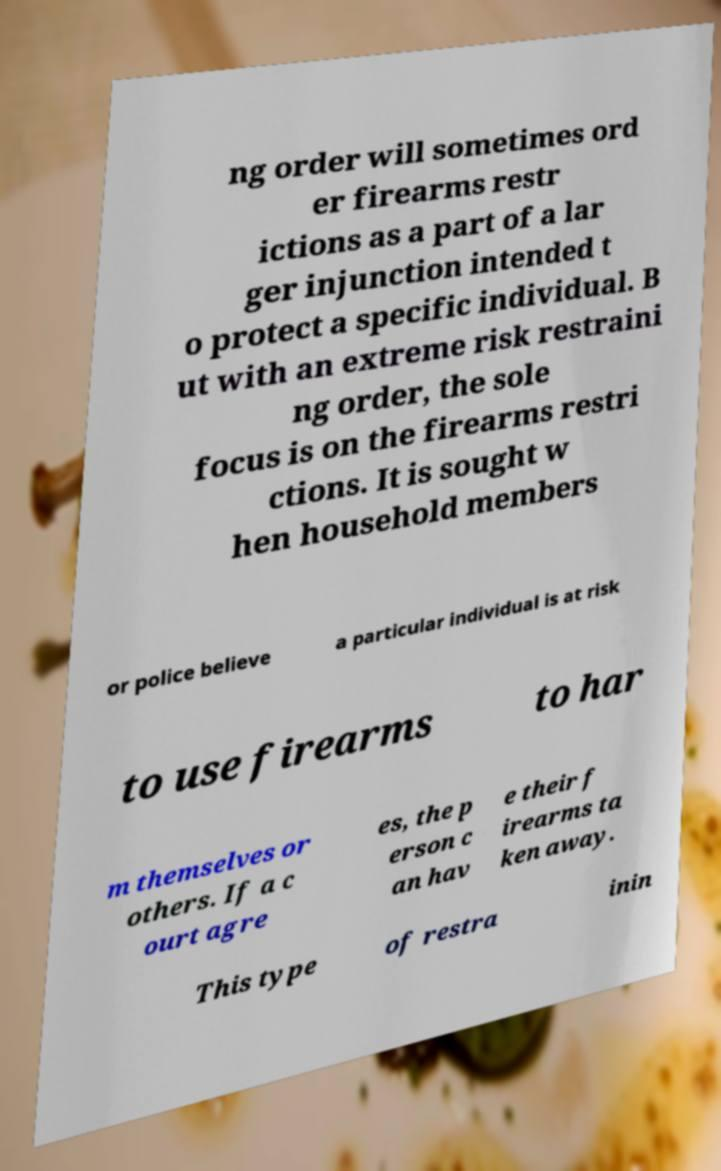Please read and relay the text visible in this image. What does it say? ng order will sometimes ord er firearms restr ictions as a part of a lar ger injunction intended t o protect a specific individual. B ut with an extreme risk restraini ng order, the sole focus is on the firearms restri ctions. It is sought w hen household members or police believe a particular individual is at risk to use firearms to har m themselves or others. If a c ourt agre es, the p erson c an hav e their f irearms ta ken away. This type of restra inin 